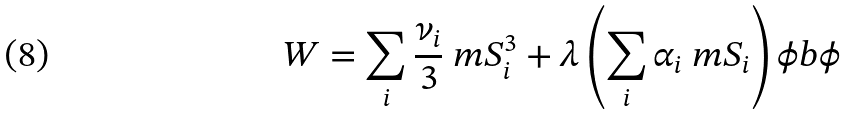Convert formula to latex. <formula><loc_0><loc_0><loc_500><loc_500>W = \sum _ { i } \frac { \nu _ { i } } { 3 } \ m S _ { i } ^ { 3 } + \lambda \left ( \sum _ { i } \alpha _ { i } \ m S _ { i } \right ) \phi b \phi</formula> 